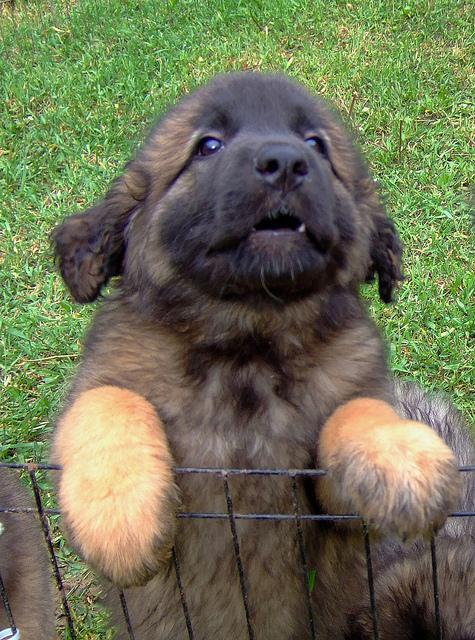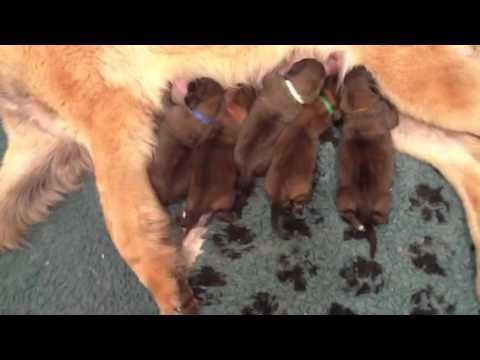The first image is the image on the left, the second image is the image on the right. Analyze the images presented: Is the assertion "Puppies are nursing on a puppy paw print rug in one of the images." valid? Answer yes or no. Yes. The first image is the image on the left, the second image is the image on the right. For the images shown, is this caption "An image shows multiple puppies on a gray rug with a paw print pattern." true? Answer yes or no. Yes. 